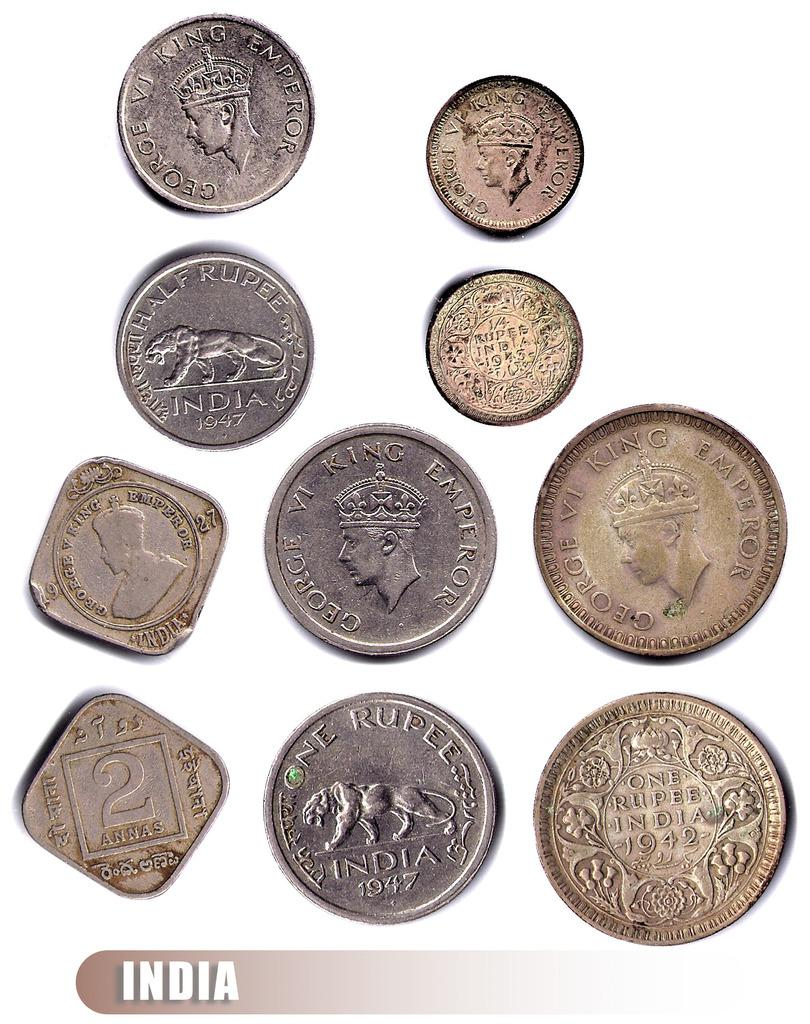<image>
Create a compact narrative representing the image presented. A bunch of gold and silver coins from India. 